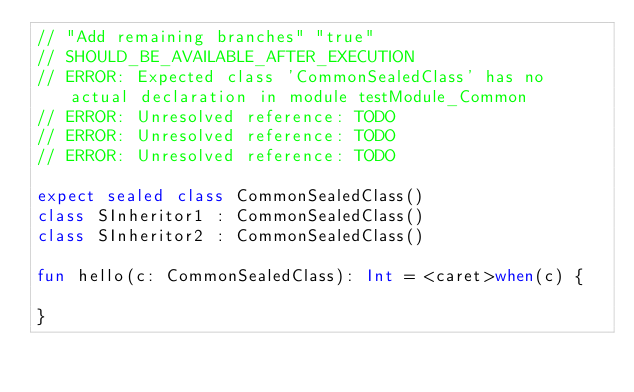Convert code to text. <code><loc_0><loc_0><loc_500><loc_500><_Kotlin_>// "Add remaining branches" "true"
// SHOULD_BE_AVAILABLE_AFTER_EXECUTION
// ERROR: Expected class 'CommonSealedClass' has no actual declaration in module testModule_Common
// ERROR: Unresolved reference: TODO
// ERROR: Unresolved reference: TODO
// ERROR: Unresolved reference: TODO

expect sealed class CommonSealedClass()
class SInheritor1 : CommonSealedClass()
class SInheritor2 : CommonSealedClass()

fun hello(c: CommonSealedClass): Int = <caret>when(c) {

}</code> 